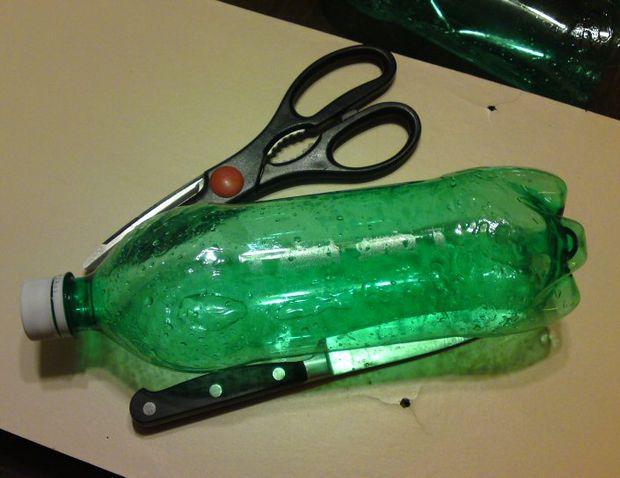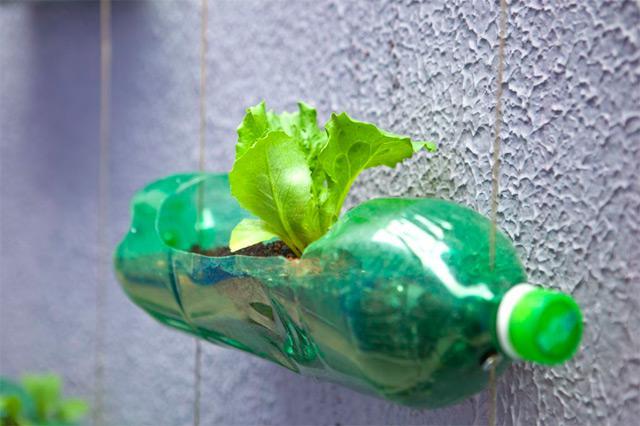The first image is the image on the left, the second image is the image on the right. For the images displayed, is the sentence "All bottles in the pair are green." factually correct? Answer yes or no. Yes. 